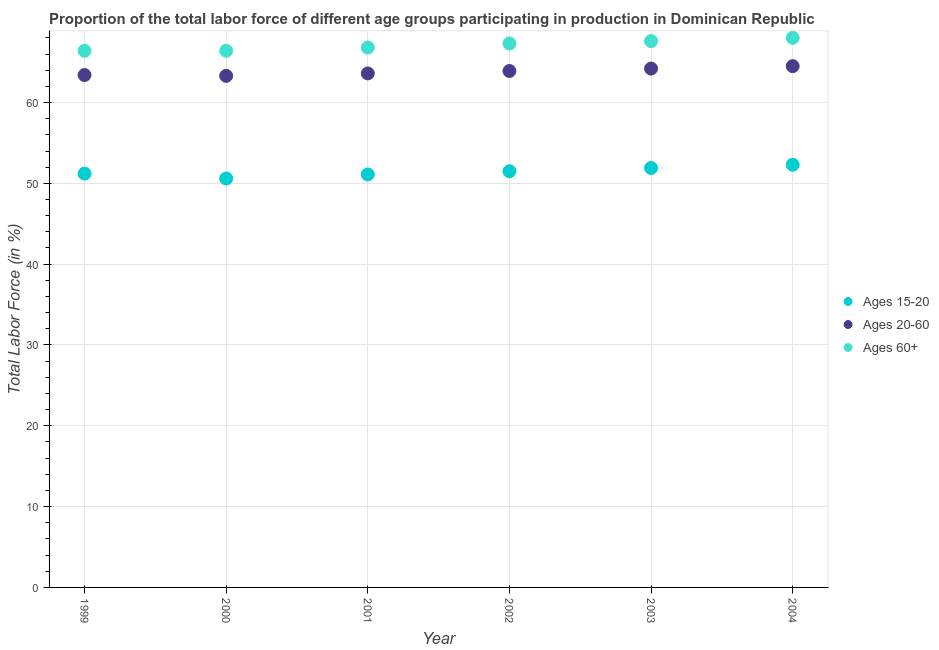What is the percentage of labor force within the age group 15-20 in 2001?
Your answer should be very brief. 51.1. Across all years, what is the maximum percentage of labor force within the age group 15-20?
Give a very brief answer. 52.3. Across all years, what is the minimum percentage of labor force within the age group 20-60?
Your answer should be very brief. 63.3. In which year was the percentage of labor force within the age group 20-60 minimum?
Provide a succinct answer. 2000. What is the total percentage of labor force above age 60 in the graph?
Your answer should be very brief. 402.5. What is the difference between the percentage of labor force above age 60 in 1999 and that in 2003?
Ensure brevity in your answer.  -1.2. What is the difference between the percentage of labor force within the age group 15-20 in 2001 and the percentage of labor force above age 60 in 2002?
Your response must be concise. -16.2. What is the average percentage of labor force within the age group 20-60 per year?
Offer a terse response. 63.82. In the year 2003, what is the difference between the percentage of labor force within the age group 15-20 and percentage of labor force above age 60?
Provide a short and direct response. -15.7. What is the ratio of the percentage of labor force above age 60 in 1999 to that in 2001?
Keep it short and to the point. 0.99. What is the difference between the highest and the second highest percentage of labor force within the age group 20-60?
Give a very brief answer. 0.3. What is the difference between the highest and the lowest percentage of labor force within the age group 20-60?
Give a very brief answer. 1.2. In how many years, is the percentage of labor force within the age group 15-20 greater than the average percentage of labor force within the age group 15-20 taken over all years?
Your answer should be very brief. 3. Is it the case that in every year, the sum of the percentage of labor force within the age group 15-20 and percentage of labor force within the age group 20-60 is greater than the percentage of labor force above age 60?
Ensure brevity in your answer.  Yes. Is the percentage of labor force within the age group 15-20 strictly greater than the percentage of labor force above age 60 over the years?
Ensure brevity in your answer.  No. Is the percentage of labor force above age 60 strictly less than the percentage of labor force within the age group 15-20 over the years?
Offer a very short reply. No. How many years are there in the graph?
Ensure brevity in your answer.  6. Are the values on the major ticks of Y-axis written in scientific E-notation?
Provide a short and direct response. No. Where does the legend appear in the graph?
Offer a terse response. Center right. How are the legend labels stacked?
Offer a very short reply. Vertical. What is the title of the graph?
Your answer should be very brief. Proportion of the total labor force of different age groups participating in production in Dominican Republic. Does "Food" appear as one of the legend labels in the graph?
Provide a short and direct response. No. What is the label or title of the X-axis?
Make the answer very short. Year. What is the Total Labor Force (in %) in Ages 15-20 in 1999?
Your response must be concise. 51.2. What is the Total Labor Force (in %) in Ages 20-60 in 1999?
Provide a short and direct response. 63.4. What is the Total Labor Force (in %) of Ages 60+ in 1999?
Your answer should be very brief. 66.4. What is the Total Labor Force (in %) of Ages 15-20 in 2000?
Provide a short and direct response. 50.6. What is the Total Labor Force (in %) of Ages 20-60 in 2000?
Your answer should be compact. 63.3. What is the Total Labor Force (in %) in Ages 60+ in 2000?
Provide a succinct answer. 66.4. What is the Total Labor Force (in %) in Ages 15-20 in 2001?
Your response must be concise. 51.1. What is the Total Labor Force (in %) of Ages 20-60 in 2001?
Offer a terse response. 63.6. What is the Total Labor Force (in %) in Ages 60+ in 2001?
Provide a succinct answer. 66.8. What is the Total Labor Force (in %) in Ages 15-20 in 2002?
Offer a very short reply. 51.5. What is the Total Labor Force (in %) of Ages 20-60 in 2002?
Keep it short and to the point. 63.9. What is the Total Labor Force (in %) in Ages 60+ in 2002?
Offer a very short reply. 67.3. What is the Total Labor Force (in %) in Ages 15-20 in 2003?
Give a very brief answer. 51.9. What is the Total Labor Force (in %) in Ages 20-60 in 2003?
Your answer should be compact. 64.2. What is the Total Labor Force (in %) of Ages 60+ in 2003?
Offer a terse response. 67.6. What is the Total Labor Force (in %) of Ages 15-20 in 2004?
Offer a terse response. 52.3. What is the Total Labor Force (in %) in Ages 20-60 in 2004?
Your answer should be compact. 64.5. Across all years, what is the maximum Total Labor Force (in %) in Ages 15-20?
Give a very brief answer. 52.3. Across all years, what is the maximum Total Labor Force (in %) of Ages 20-60?
Your answer should be compact. 64.5. Across all years, what is the maximum Total Labor Force (in %) in Ages 60+?
Your answer should be very brief. 68. Across all years, what is the minimum Total Labor Force (in %) in Ages 15-20?
Keep it short and to the point. 50.6. Across all years, what is the minimum Total Labor Force (in %) in Ages 20-60?
Your answer should be compact. 63.3. Across all years, what is the minimum Total Labor Force (in %) in Ages 60+?
Provide a succinct answer. 66.4. What is the total Total Labor Force (in %) of Ages 15-20 in the graph?
Ensure brevity in your answer.  308.6. What is the total Total Labor Force (in %) in Ages 20-60 in the graph?
Provide a succinct answer. 382.9. What is the total Total Labor Force (in %) in Ages 60+ in the graph?
Keep it short and to the point. 402.5. What is the difference between the Total Labor Force (in %) of Ages 15-20 in 1999 and that in 2000?
Your answer should be very brief. 0.6. What is the difference between the Total Labor Force (in %) of Ages 20-60 in 1999 and that in 2001?
Your answer should be very brief. -0.2. What is the difference between the Total Labor Force (in %) of Ages 15-20 in 1999 and that in 2002?
Your answer should be compact. -0.3. What is the difference between the Total Labor Force (in %) of Ages 20-60 in 1999 and that in 2002?
Make the answer very short. -0.5. What is the difference between the Total Labor Force (in %) in Ages 15-20 in 1999 and that in 2003?
Offer a very short reply. -0.7. What is the difference between the Total Labor Force (in %) in Ages 20-60 in 1999 and that in 2003?
Give a very brief answer. -0.8. What is the difference between the Total Labor Force (in %) in Ages 60+ in 1999 and that in 2003?
Offer a very short reply. -1.2. What is the difference between the Total Labor Force (in %) in Ages 20-60 in 1999 and that in 2004?
Your answer should be very brief. -1.1. What is the difference between the Total Labor Force (in %) of Ages 15-20 in 2000 and that in 2001?
Offer a terse response. -0.5. What is the difference between the Total Labor Force (in %) in Ages 15-20 in 2000 and that in 2002?
Your answer should be very brief. -0.9. What is the difference between the Total Labor Force (in %) of Ages 60+ in 2000 and that in 2002?
Offer a very short reply. -0.9. What is the difference between the Total Labor Force (in %) in Ages 15-20 in 2000 and that in 2004?
Keep it short and to the point. -1.7. What is the difference between the Total Labor Force (in %) of Ages 20-60 in 2000 and that in 2004?
Your answer should be very brief. -1.2. What is the difference between the Total Labor Force (in %) in Ages 15-20 in 2001 and that in 2002?
Your answer should be compact. -0.4. What is the difference between the Total Labor Force (in %) in Ages 20-60 in 2001 and that in 2003?
Provide a succinct answer. -0.6. What is the difference between the Total Labor Force (in %) in Ages 60+ in 2001 and that in 2003?
Provide a succinct answer. -0.8. What is the difference between the Total Labor Force (in %) of Ages 20-60 in 2001 and that in 2004?
Provide a succinct answer. -0.9. What is the difference between the Total Labor Force (in %) of Ages 20-60 in 2002 and that in 2003?
Your response must be concise. -0.3. What is the difference between the Total Labor Force (in %) in Ages 60+ in 2002 and that in 2003?
Your answer should be very brief. -0.3. What is the difference between the Total Labor Force (in %) in Ages 15-20 in 2002 and that in 2004?
Your answer should be compact. -0.8. What is the difference between the Total Labor Force (in %) in Ages 20-60 in 2002 and that in 2004?
Your answer should be very brief. -0.6. What is the difference between the Total Labor Force (in %) in Ages 15-20 in 2003 and that in 2004?
Offer a terse response. -0.4. What is the difference between the Total Labor Force (in %) of Ages 60+ in 2003 and that in 2004?
Your answer should be compact. -0.4. What is the difference between the Total Labor Force (in %) of Ages 15-20 in 1999 and the Total Labor Force (in %) of Ages 60+ in 2000?
Offer a terse response. -15.2. What is the difference between the Total Labor Force (in %) of Ages 20-60 in 1999 and the Total Labor Force (in %) of Ages 60+ in 2000?
Make the answer very short. -3. What is the difference between the Total Labor Force (in %) in Ages 15-20 in 1999 and the Total Labor Force (in %) in Ages 60+ in 2001?
Keep it short and to the point. -15.6. What is the difference between the Total Labor Force (in %) of Ages 15-20 in 1999 and the Total Labor Force (in %) of Ages 60+ in 2002?
Keep it short and to the point. -16.1. What is the difference between the Total Labor Force (in %) in Ages 15-20 in 1999 and the Total Labor Force (in %) in Ages 20-60 in 2003?
Provide a short and direct response. -13. What is the difference between the Total Labor Force (in %) of Ages 15-20 in 1999 and the Total Labor Force (in %) of Ages 60+ in 2003?
Offer a terse response. -16.4. What is the difference between the Total Labor Force (in %) of Ages 15-20 in 1999 and the Total Labor Force (in %) of Ages 20-60 in 2004?
Offer a very short reply. -13.3. What is the difference between the Total Labor Force (in %) of Ages 15-20 in 1999 and the Total Labor Force (in %) of Ages 60+ in 2004?
Provide a short and direct response. -16.8. What is the difference between the Total Labor Force (in %) of Ages 15-20 in 2000 and the Total Labor Force (in %) of Ages 20-60 in 2001?
Provide a succinct answer. -13. What is the difference between the Total Labor Force (in %) in Ages 15-20 in 2000 and the Total Labor Force (in %) in Ages 60+ in 2001?
Your answer should be very brief. -16.2. What is the difference between the Total Labor Force (in %) in Ages 15-20 in 2000 and the Total Labor Force (in %) in Ages 20-60 in 2002?
Give a very brief answer. -13.3. What is the difference between the Total Labor Force (in %) of Ages 15-20 in 2000 and the Total Labor Force (in %) of Ages 60+ in 2002?
Your response must be concise. -16.7. What is the difference between the Total Labor Force (in %) in Ages 20-60 in 2000 and the Total Labor Force (in %) in Ages 60+ in 2003?
Make the answer very short. -4.3. What is the difference between the Total Labor Force (in %) in Ages 15-20 in 2000 and the Total Labor Force (in %) in Ages 20-60 in 2004?
Offer a terse response. -13.9. What is the difference between the Total Labor Force (in %) of Ages 15-20 in 2000 and the Total Labor Force (in %) of Ages 60+ in 2004?
Provide a short and direct response. -17.4. What is the difference between the Total Labor Force (in %) of Ages 20-60 in 2000 and the Total Labor Force (in %) of Ages 60+ in 2004?
Your response must be concise. -4.7. What is the difference between the Total Labor Force (in %) in Ages 15-20 in 2001 and the Total Labor Force (in %) in Ages 60+ in 2002?
Provide a succinct answer. -16.2. What is the difference between the Total Labor Force (in %) of Ages 15-20 in 2001 and the Total Labor Force (in %) of Ages 20-60 in 2003?
Your answer should be very brief. -13.1. What is the difference between the Total Labor Force (in %) in Ages 15-20 in 2001 and the Total Labor Force (in %) in Ages 60+ in 2003?
Your answer should be very brief. -16.5. What is the difference between the Total Labor Force (in %) in Ages 20-60 in 2001 and the Total Labor Force (in %) in Ages 60+ in 2003?
Offer a terse response. -4. What is the difference between the Total Labor Force (in %) in Ages 15-20 in 2001 and the Total Labor Force (in %) in Ages 60+ in 2004?
Give a very brief answer. -16.9. What is the difference between the Total Labor Force (in %) in Ages 20-60 in 2001 and the Total Labor Force (in %) in Ages 60+ in 2004?
Your answer should be compact. -4.4. What is the difference between the Total Labor Force (in %) of Ages 15-20 in 2002 and the Total Labor Force (in %) of Ages 60+ in 2003?
Offer a terse response. -16.1. What is the difference between the Total Labor Force (in %) in Ages 15-20 in 2002 and the Total Labor Force (in %) in Ages 20-60 in 2004?
Provide a succinct answer. -13. What is the difference between the Total Labor Force (in %) of Ages 15-20 in 2002 and the Total Labor Force (in %) of Ages 60+ in 2004?
Your answer should be compact. -16.5. What is the difference between the Total Labor Force (in %) in Ages 20-60 in 2002 and the Total Labor Force (in %) in Ages 60+ in 2004?
Offer a very short reply. -4.1. What is the difference between the Total Labor Force (in %) in Ages 15-20 in 2003 and the Total Labor Force (in %) in Ages 20-60 in 2004?
Offer a terse response. -12.6. What is the difference between the Total Labor Force (in %) of Ages 15-20 in 2003 and the Total Labor Force (in %) of Ages 60+ in 2004?
Ensure brevity in your answer.  -16.1. What is the average Total Labor Force (in %) of Ages 15-20 per year?
Ensure brevity in your answer.  51.43. What is the average Total Labor Force (in %) of Ages 20-60 per year?
Ensure brevity in your answer.  63.82. What is the average Total Labor Force (in %) in Ages 60+ per year?
Your answer should be compact. 67.08. In the year 1999, what is the difference between the Total Labor Force (in %) in Ages 15-20 and Total Labor Force (in %) in Ages 20-60?
Offer a terse response. -12.2. In the year 1999, what is the difference between the Total Labor Force (in %) of Ages 15-20 and Total Labor Force (in %) of Ages 60+?
Your answer should be compact. -15.2. In the year 2000, what is the difference between the Total Labor Force (in %) in Ages 15-20 and Total Labor Force (in %) in Ages 60+?
Your answer should be compact. -15.8. In the year 2001, what is the difference between the Total Labor Force (in %) of Ages 15-20 and Total Labor Force (in %) of Ages 20-60?
Keep it short and to the point. -12.5. In the year 2001, what is the difference between the Total Labor Force (in %) in Ages 15-20 and Total Labor Force (in %) in Ages 60+?
Make the answer very short. -15.7. In the year 2002, what is the difference between the Total Labor Force (in %) in Ages 15-20 and Total Labor Force (in %) in Ages 20-60?
Your response must be concise. -12.4. In the year 2002, what is the difference between the Total Labor Force (in %) of Ages 15-20 and Total Labor Force (in %) of Ages 60+?
Ensure brevity in your answer.  -15.8. In the year 2003, what is the difference between the Total Labor Force (in %) in Ages 15-20 and Total Labor Force (in %) in Ages 60+?
Give a very brief answer. -15.7. In the year 2003, what is the difference between the Total Labor Force (in %) of Ages 20-60 and Total Labor Force (in %) of Ages 60+?
Offer a very short reply. -3.4. In the year 2004, what is the difference between the Total Labor Force (in %) in Ages 15-20 and Total Labor Force (in %) in Ages 20-60?
Provide a short and direct response. -12.2. In the year 2004, what is the difference between the Total Labor Force (in %) of Ages 15-20 and Total Labor Force (in %) of Ages 60+?
Give a very brief answer. -15.7. In the year 2004, what is the difference between the Total Labor Force (in %) of Ages 20-60 and Total Labor Force (in %) of Ages 60+?
Offer a terse response. -3.5. What is the ratio of the Total Labor Force (in %) of Ages 15-20 in 1999 to that in 2000?
Ensure brevity in your answer.  1.01. What is the ratio of the Total Labor Force (in %) of Ages 20-60 in 1999 to that in 2000?
Your answer should be compact. 1. What is the ratio of the Total Labor Force (in %) of Ages 60+ in 1999 to that in 2001?
Ensure brevity in your answer.  0.99. What is the ratio of the Total Labor Force (in %) of Ages 15-20 in 1999 to that in 2002?
Make the answer very short. 0.99. What is the ratio of the Total Labor Force (in %) in Ages 60+ in 1999 to that in 2002?
Keep it short and to the point. 0.99. What is the ratio of the Total Labor Force (in %) in Ages 15-20 in 1999 to that in 2003?
Keep it short and to the point. 0.99. What is the ratio of the Total Labor Force (in %) in Ages 20-60 in 1999 to that in 2003?
Ensure brevity in your answer.  0.99. What is the ratio of the Total Labor Force (in %) in Ages 60+ in 1999 to that in 2003?
Offer a very short reply. 0.98. What is the ratio of the Total Labor Force (in %) in Ages 20-60 in 1999 to that in 2004?
Offer a terse response. 0.98. What is the ratio of the Total Labor Force (in %) of Ages 60+ in 1999 to that in 2004?
Make the answer very short. 0.98. What is the ratio of the Total Labor Force (in %) in Ages 15-20 in 2000 to that in 2001?
Offer a terse response. 0.99. What is the ratio of the Total Labor Force (in %) in Ages 20-60 in 2000 to that in 2001?
Provide a short and direct response. 1. What is the ratio of the Total Labor Force (in %) in Ages 60+ in 2000 to that in 2001?
Give a very brief answer. 0.99. What is the ratio of the Total Labor Force (in %) in Ages 15-20 in 2000 to that in 2002?
Your response must be concise. 0.98. What is the ratio of the Total Labor Force (in %) of Ages 20-60 in 2000 to that in 2002?
Your answer should be compact. 0.99. What is the ratio of the Total Labor Force (in %) in Ages 60+ in 2000 to that in 2002?
Your answer should be compact. 0.99. What is the ratio of the Total Labor Force (in %) of Ages 15-20 in 2000 to that in 2003?
Ensure brevity in your answer.  0.97. What is the ratio of the Total Labor Force (in %) of Ages 60+ in 2000 to that in 2003?
Provide a succinct answer. 0.98. What is the ratio of the Total Labor Force (in %) of Ages 15-20 in 2000 to that in 2004?
Offer a terse response. 0.97. What is the ratio of the Total Labor Force (in %) of Ages 20-60 in 2000 to that in 2004?
Offer a terse response. 0.98. What is the ratio of the Total Labor Force (in %) in Ages 60+ in 2000 to that in 2004?
Your response must be concise. 0.98. What is the ratio of the Total Labor Force (in %) in Ages 20-60 in 2001 to that in 2002?
Make the answer very short. 1. What is the ratio of the Total Labor Force (in %) of Ages 60+ in 2001 to that in 2002?
Provide a succinct answer. 0.99. What is the ratio of the Total Labor Force (in %) in Ages 15-20 in 2001 to that in 2003?
Your answer should be compact. 0.98. What is the ratio of the Total Labor Force (in %) in Ages 15-20 in 2001 to that in 2004?
Provide a short and direct response. 0.98. What is the ratio of the Total Labor Force (in %) in Ages 60+ in 2001 to that in 2004?
Your answer should be very brief. 0.98. What is the ratio of the Total Labor Force (in %) in Ages 15-20 in 2002 to that in 2003?
Make the answer very short. 0.99. What is the ratio of the Total Labor Force (in %) in Ages 15-20 in 2002 to that in 2004?
Ensure brevity in your answer.  0.98. What is the ratio of the Total Labor Force (in %) of Ages 20-60 in 2003 to that in 2004?
Make the answer very short. 1. What is the ratio of the Total Labor Force (in %) of Ages 60+ in 2003 to that in 2004?
Ensure brevity in your answer.  0.99. What is the difference between the highest and the second highest Total Labor Force (in %) in Ages 20-60?
Your answer should be very brief. 0.3. What is the difference between the highest and the lowest Total Labor Force (in %) in Ages 20-60?
Provide a succinct answer. 1.2. 